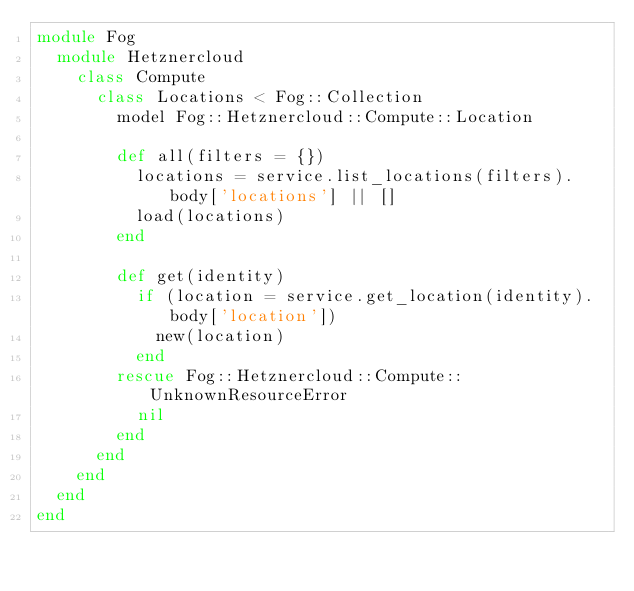<code> <loc_0><loc_0><loc_500><loc_500><_Ruby_>module Fog
  module Hetznercloud
    class Compute
      class Locations < Fog::Collection
        model Fog::Hetznercloud::Compute::Location

        def all(filters = {})
          locations = service.list_locations(filters).body['locations'] || []
          load(locations)
        end

        def get(identity)
          if (location = service.get_location(identity).body['location'])
            new(location)
          end
        rescue Fog::Hetznercloud::Compute::UnknownResourceError
          nil
        end
      end
    end
  end
end
</code> 